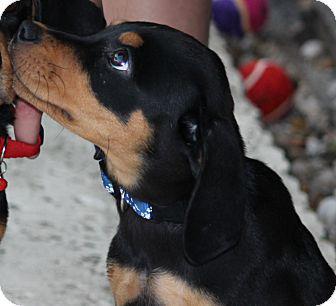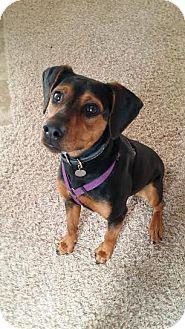The first image is the image on the left, the second image is the image on the right. Examine the images to the left and right. Is the description "A dog is sitting on carpet." accurate? Answer yes or no. Yes. The first image is the image on the left, the second image is the image on the right. Assess this claim about the two images: "In at least one image there is a black and brown dog leaning right with its head tilted forward right.". Correct or not? Answer yes or no. No. 